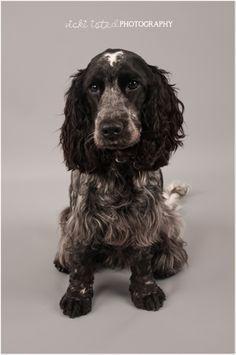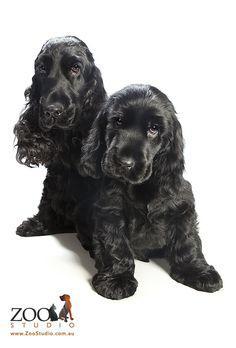The first image is the image on the left, the second image is the image on the right. Assess this claim about the two images: "One of the images contains a black and white dog with its head turned to the right.". Correct or not? Answer yes or no. No. The first image is the image on the left, the second image is the image on the right. For the images shown, is this caption "in the right pic the dogs tongue can be seen" true? Answer yes or no. No. 